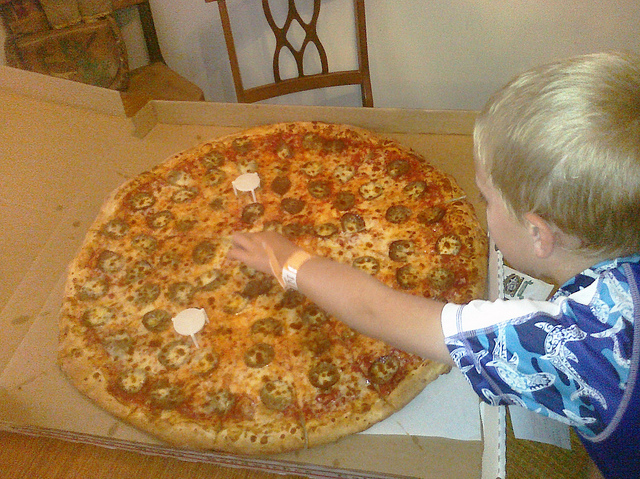<image>What topping is the boy picking off of the pizza? I can't be sure. The boy could be picking off various toppings from the pizza, such as peppers, pepperoni, jalapenos or olives. What topping is the boy picking off of the pizza? I am not sure what topping the boy is picking off of the pizza. It can be peppers, pepperoni, jalapenos, olives, or something else. 